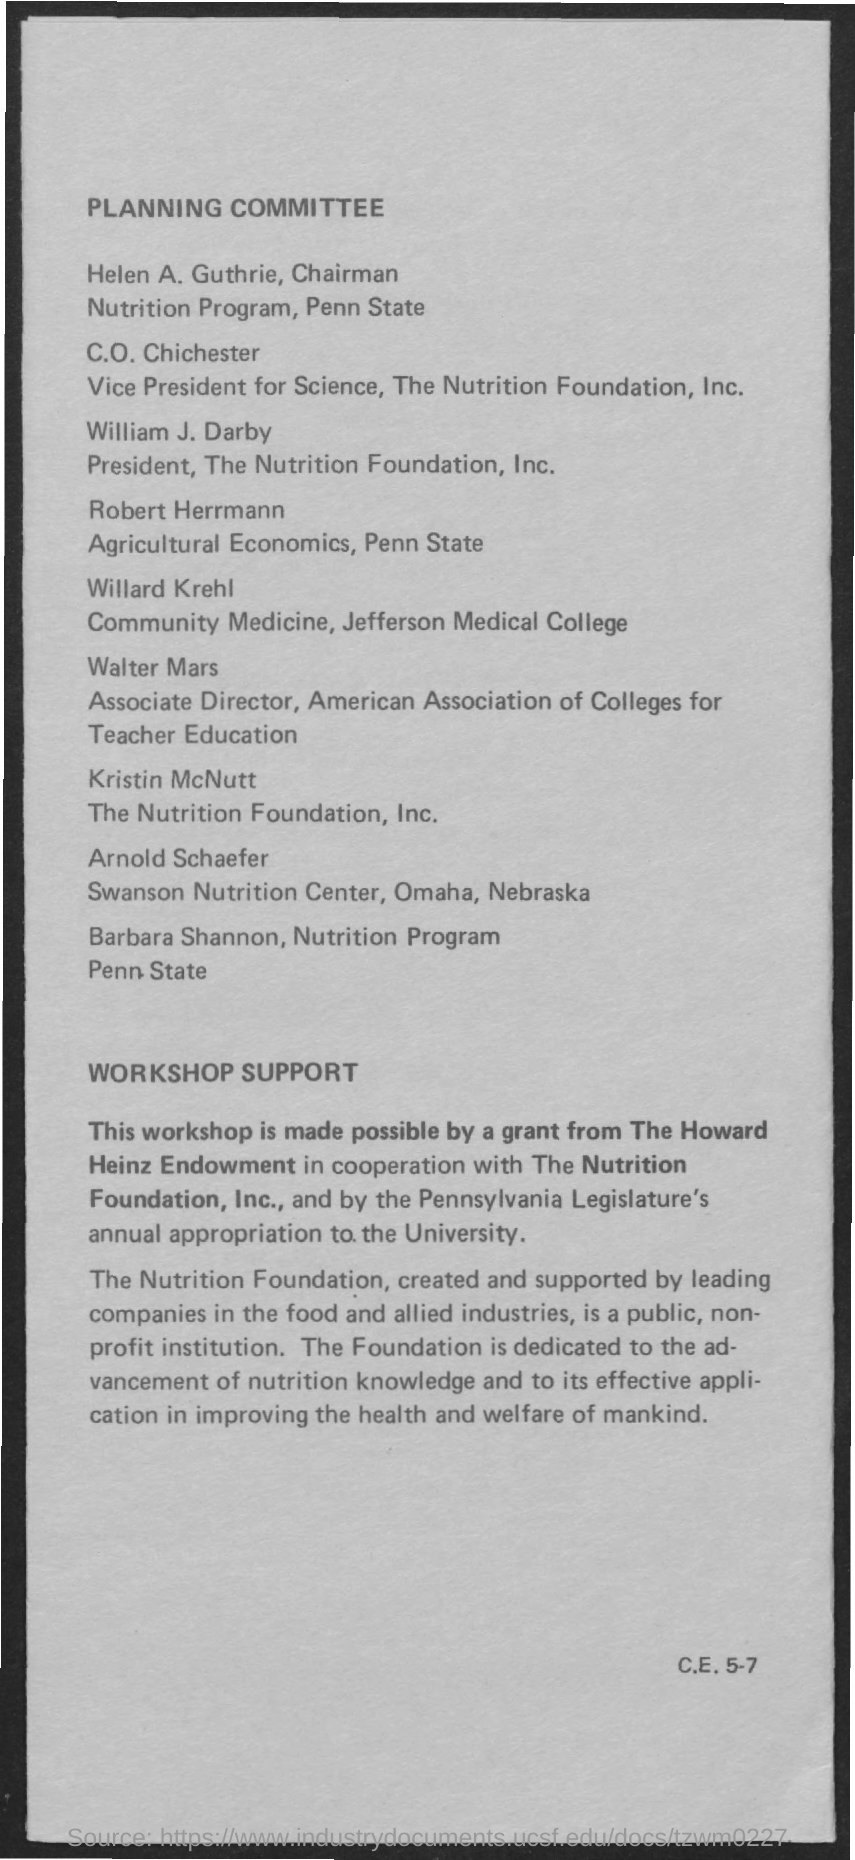Indicate a few pertinent items in this graphic. Helen A. Guthrie is the Chairman of the Nutrition Program at Penn State University. The President of the Nutrition Foundation, Inc. is William J. Darby. 